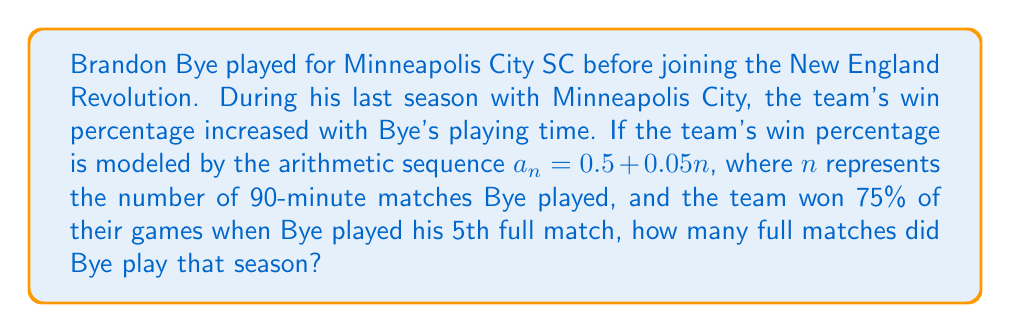Can you answer this question? Let's approach this step-by-step:

1) The arithmetic sequence is given by $a_n = 0.5 + 0.05n$, where:
   - $a_n$ is the win percentage
   - $n$ is the number of 90-minute matches Bye played

2) We're told that when Bye played his 5th full match, the team won 75% of their games.
   This means that $a_5 = 0.75$

3) Let's use the sequence formula to set up an equation:
   $$a_5 = 0.5 + 0.05(5) = 0.75$$

4) Now, let's solve for the total number of matches, which we'll call $x$:
   $$a_x = 0.5 + 0.05x = 1$$
   
   (We use 1 here because 100% is the maximum possible win percentage)

5) Solving the equation:
   $$0.5 + 0.05x = 1$$
   $$0.05x = 0.5$$
   $$x = 10$$

Therefore, Bye played 10 full matches that season.
Answer: 10 matches 